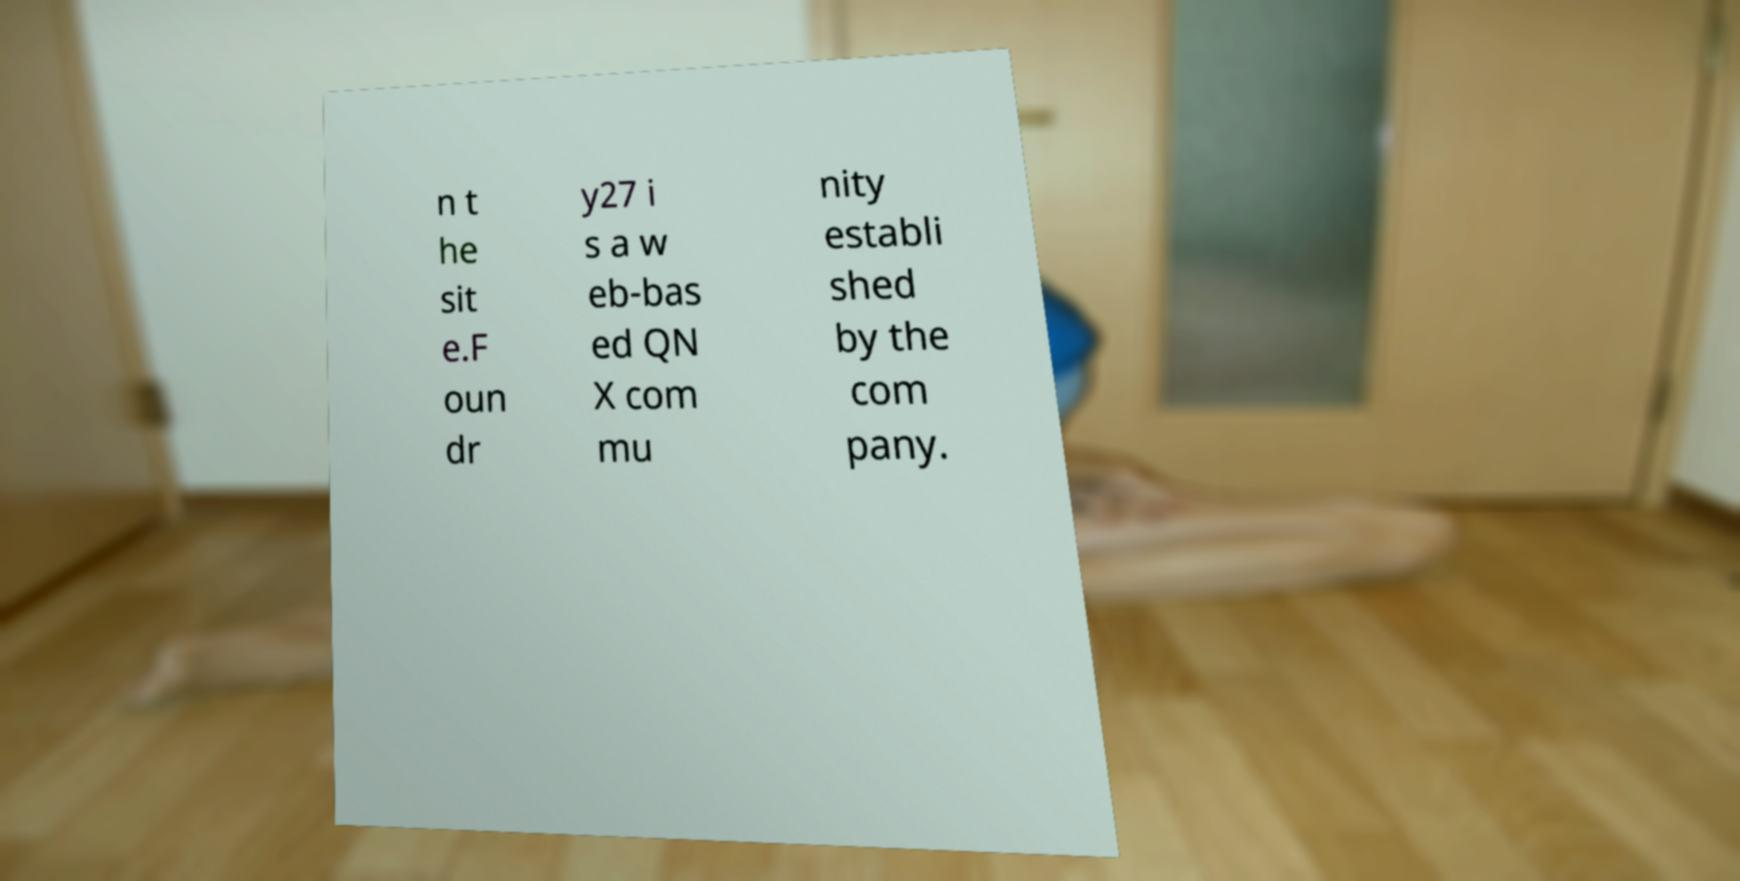Can you read and provide the text displayed in the image?This photo seems to have some interesting text. Can you extract and type it out for me? n t he sit e.F oun dr y27 i s a w eb-bas ed QN X com mu nity establi shed by the com pany. 